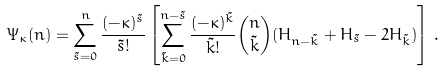Convert formula to latex. <formula><loc_0><loc_0><loc_500><loc_500>\Psi _ { \kappa } ( n ) = \sum _ { \tilde { s } = 0 } ^ { n } \frac { ( - \kappa ) ^ { \tilde { s } } } { \tilde { s } ! } \left [ \sum _ { \tilde { k } = 0 } ^ { n - \tilde { s } } \frac { ( - \kappa ) ^ { \tilde { k } } } { \tilde { k } ! } \binom { n } { \tilde { k } } ( H _ { n - \tilde { k } } + H _ { \tilde { s } } - 2 H _ { \tilde { k } } ) \right ] \, .</formula> 